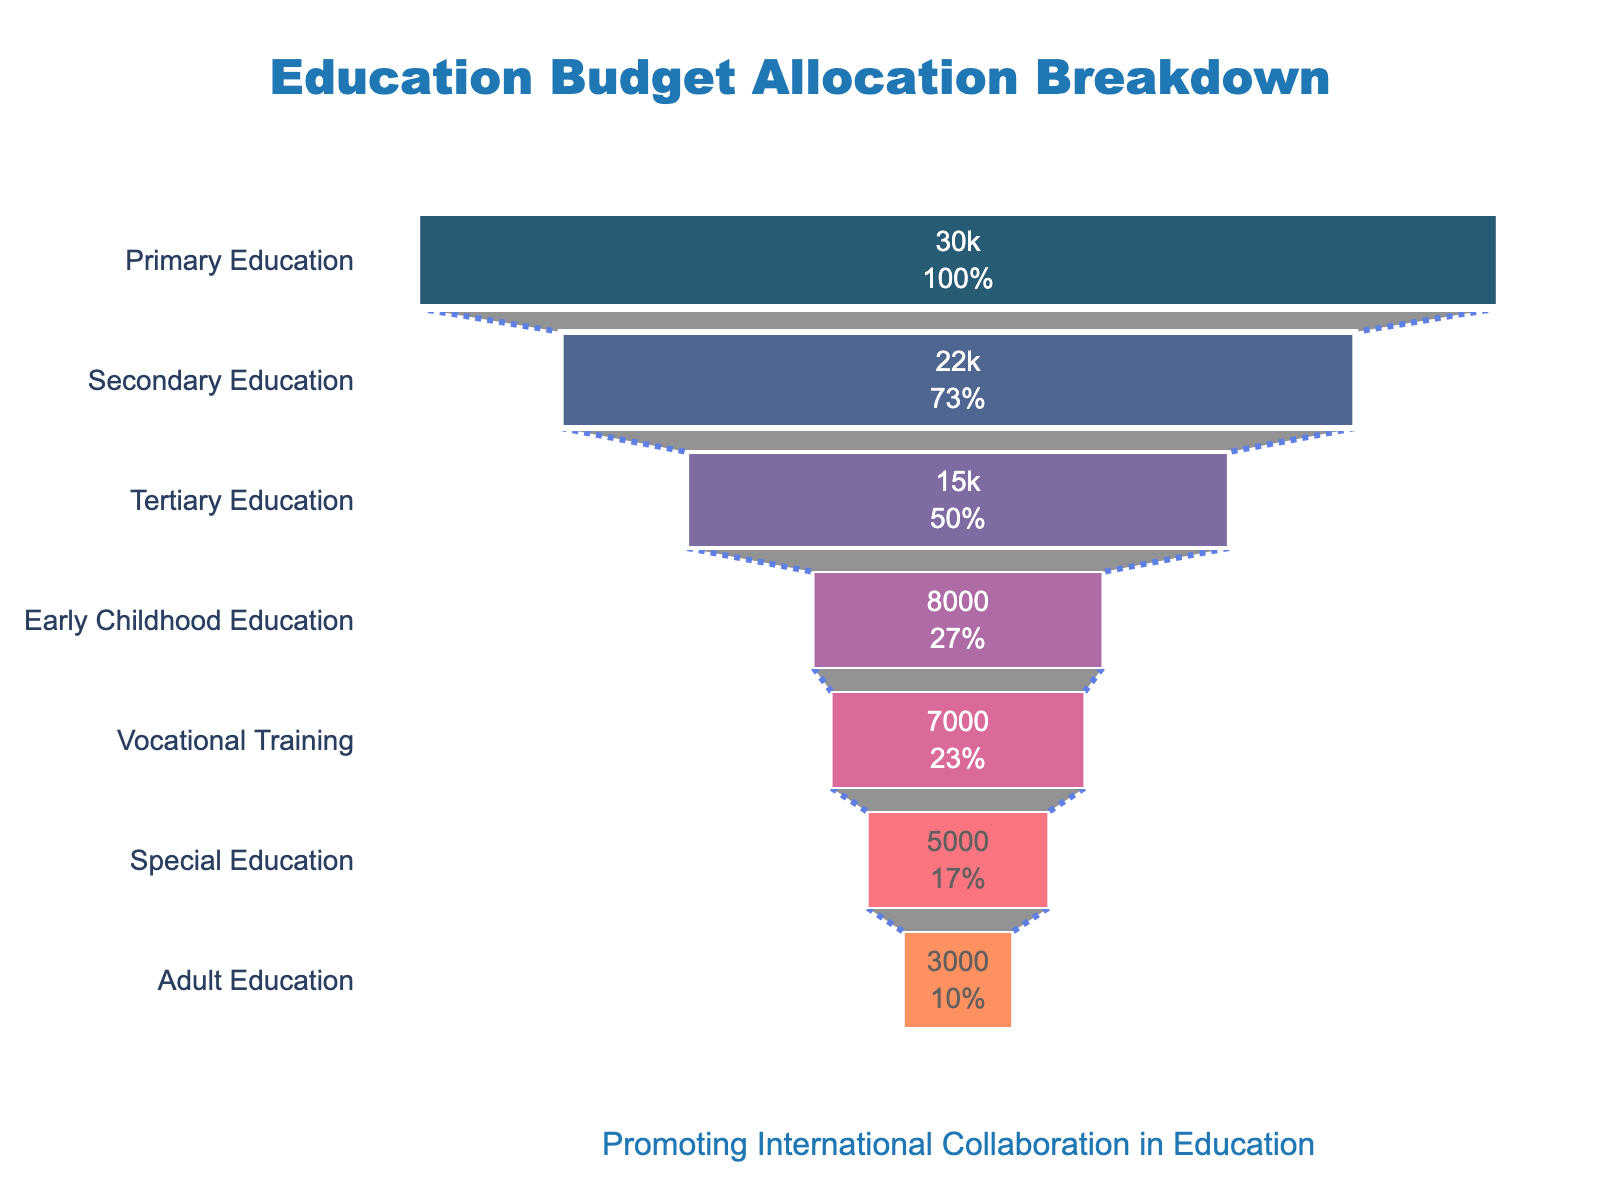What's the title of the chart? The title of the chart is the text prominently displayed at the top of the figure.
Answer: Education Budget Allocation Breakdown Which sector has the highest budget allocation? The sector with the highest budget allocation is the one shown at the widest part of the funnel.
Answer: Primary Education What is the budget allocation for Adult Education? The budget allocation for Adult Education is a specific value shown inside the corresponding section of the funnel.
Answer: 3000 Million USD How much more budget is allocated to Secondary Education compared to Vocational Training? The budget for Secondary Education is 22000 Million USD and for Vocational Training is 7000 Million USD; the difference is calculated by subtracting the latter from the former (22000 - 7000).
Answer: 15000 Million USD Which sector receives the least amount of budget? The sector at the narrowest end of the funnel receives the least amount of budget.
Answer: Adult Education Calculate the total budget allocation for all sectors combined. Add the budget allocations for all sectors: 15000 (Tertiary) + 22000 (Secondary) + 30000 (Primary) + 8000 (Early Childhood) + 5000 (Special) + 3000 (Adult) + 7000 (Vocational).
Answer: 90000 Million USD Between Primary Education and Early Childhood Education, which sector has a lower budget allocation and by how much? Primary Education has 30000 Million USD, and Early Childhood Education has 8000 Million USD; the difference is calculated by subtracting the budget of Early Childhood from Primary Education (30000 - 8000).
Answer: Early Childhood Education by 22000 Million USD What percentage of the total budget is allocated to Secondary Education? First, find the total budget (90000 Million USD). Then, the percentage can be calculated by (22000 / 90000) * 100.
Answer: 24.44% Identify the sectors that have a budget allocation greater than 10000 Million USD. The sectors with a budget allocation of more than 10000 Million USD are those for which the allocated amount exceeds 10000.
Answer: Tertiary Education, Secondary Education, Primary Education Compare the budget allocated between Special Education and Vocational Training and determine which is higher. The budget for Special Education is 5000 Million USD, and for Vocational Training, it is 7000 Million USD. By comparing the two values, we note that 7000 is higher than 5000.
Answer: Vocational Training 